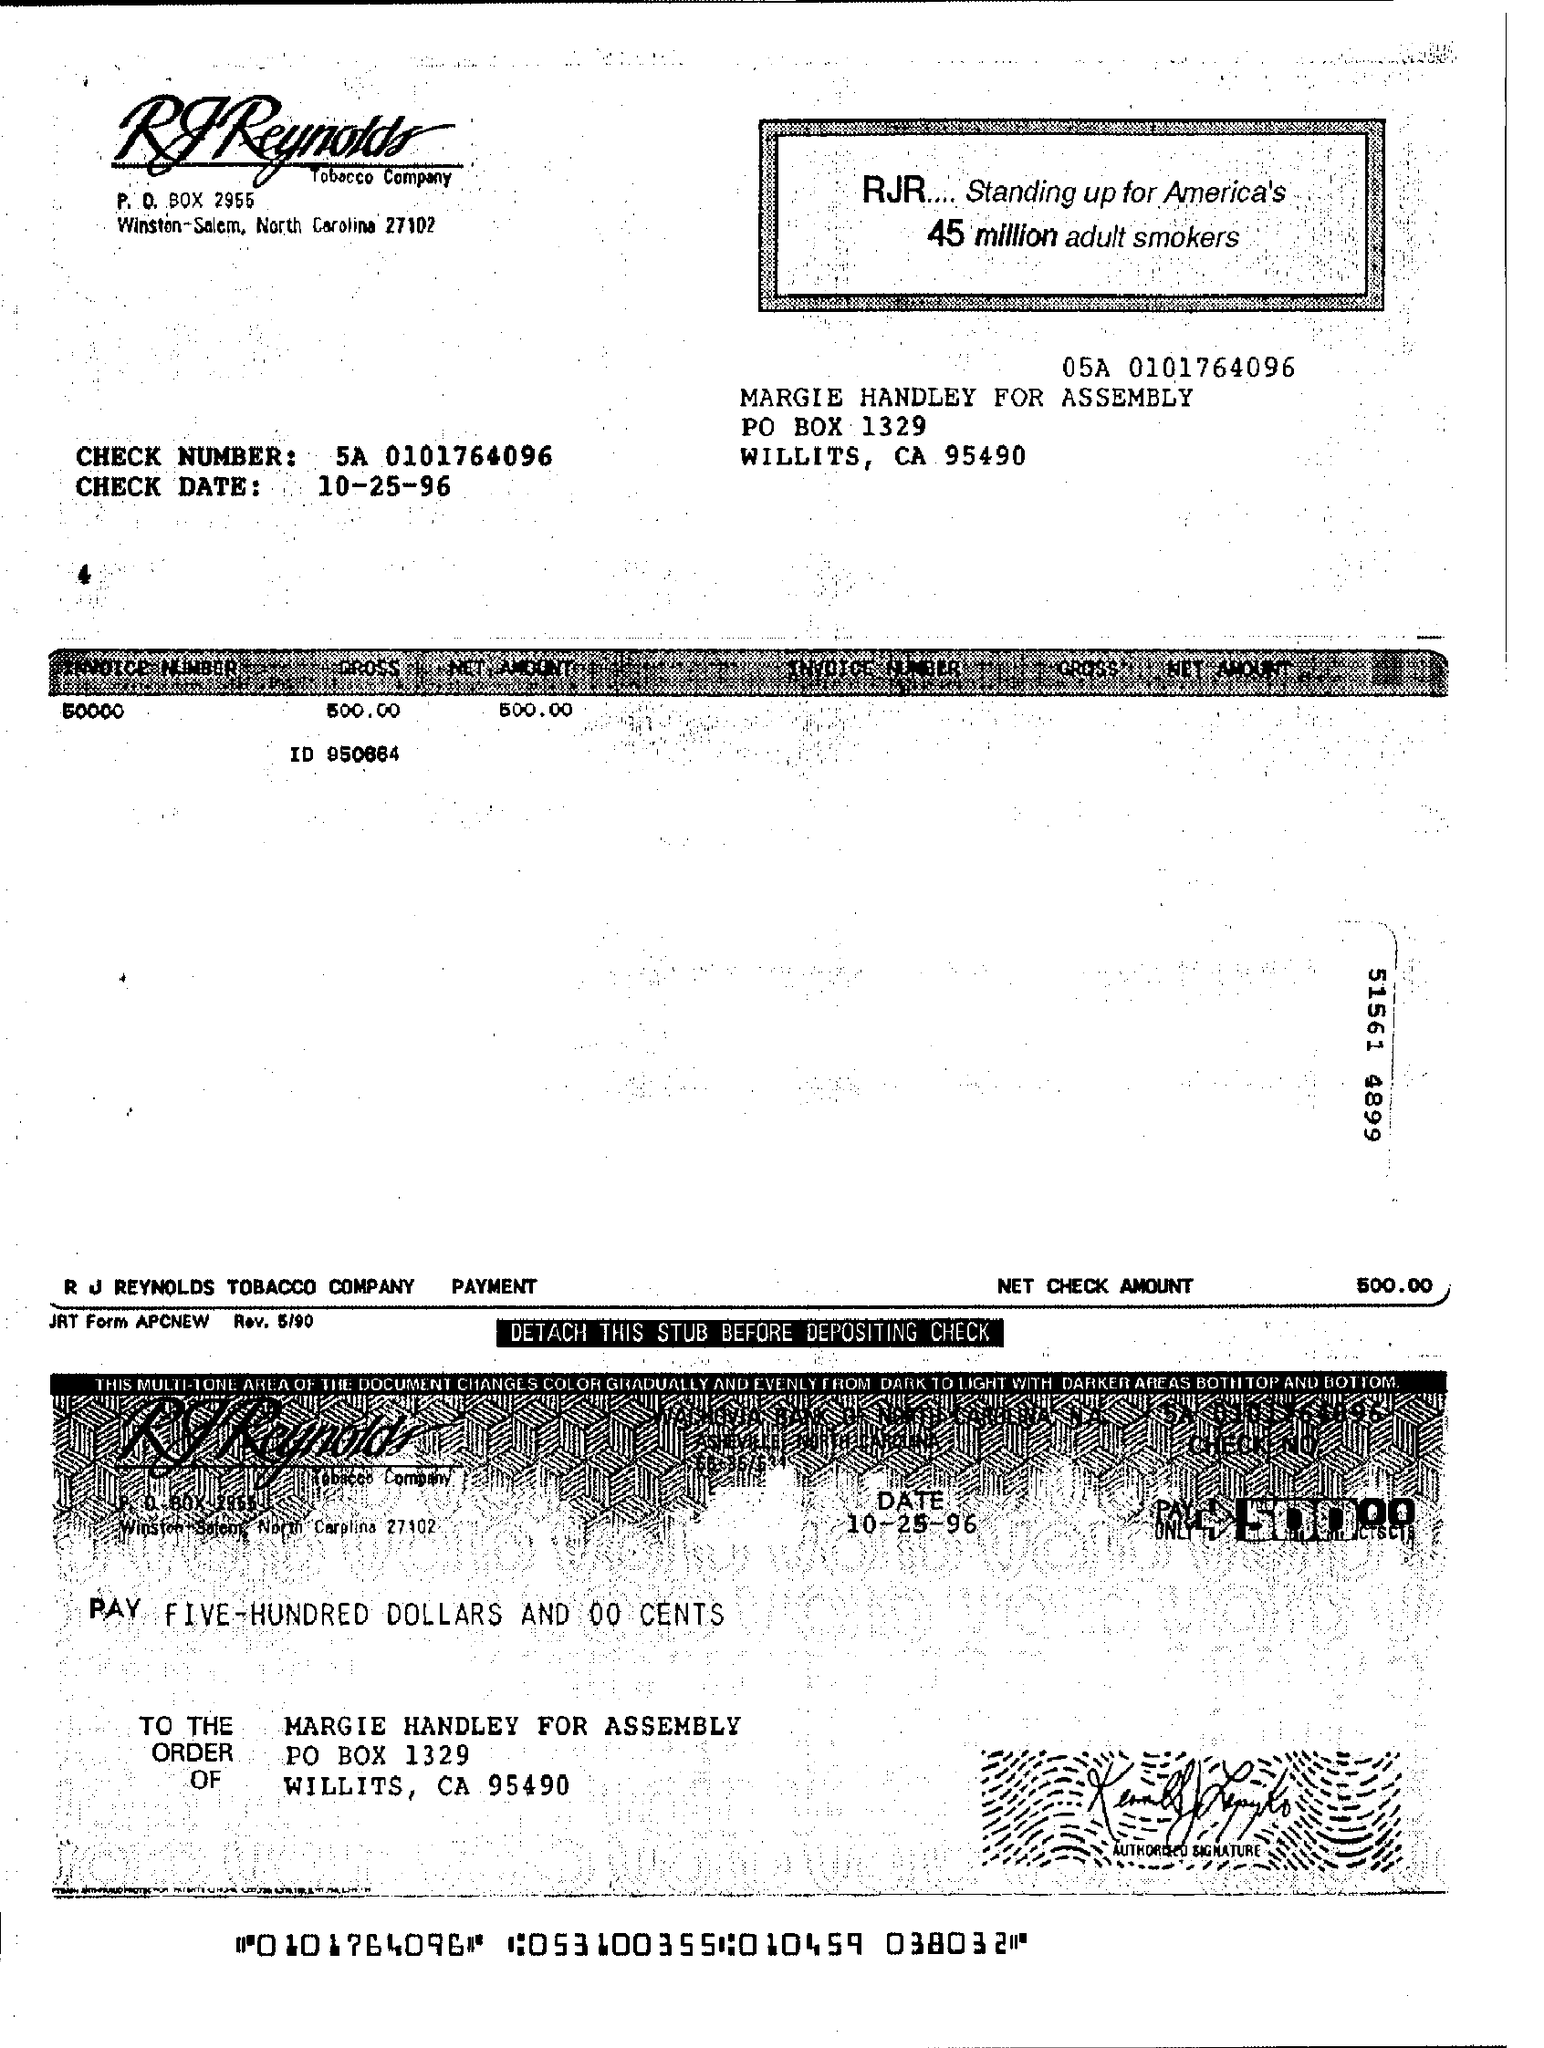Identify some key points in this picture. The check number is 5A, and the routing number is 0101764096. The invoice number is 50000. The check date is October 25, 1996. 